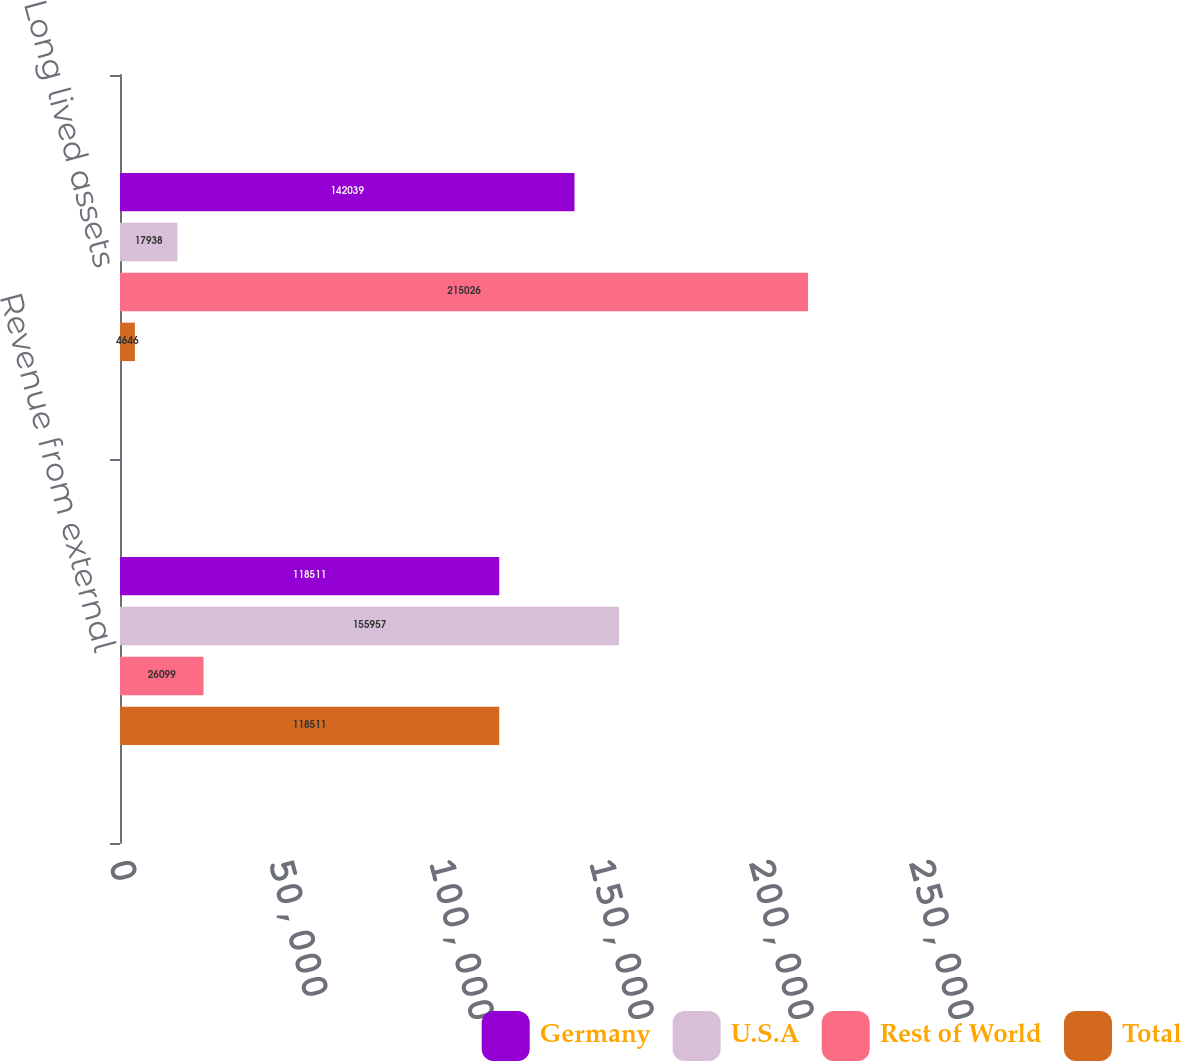Convert chart to OTSL. <chart><loc_0><loc_0><loc_500><loc_500><stacked_bar_chart><ecel><fcel>Revenue from external<fcel>Long lived assets<nl><fcel>Germany<fcel>118511<fcel>142039<nl><fcel>U.S.A<fcel>155957<fcel>17938<nl><fcel>Rest of World<fcel>26099<fcel>215026<nl><fcel>Total<fcel>118511<fcel>4646<nl></chart> 